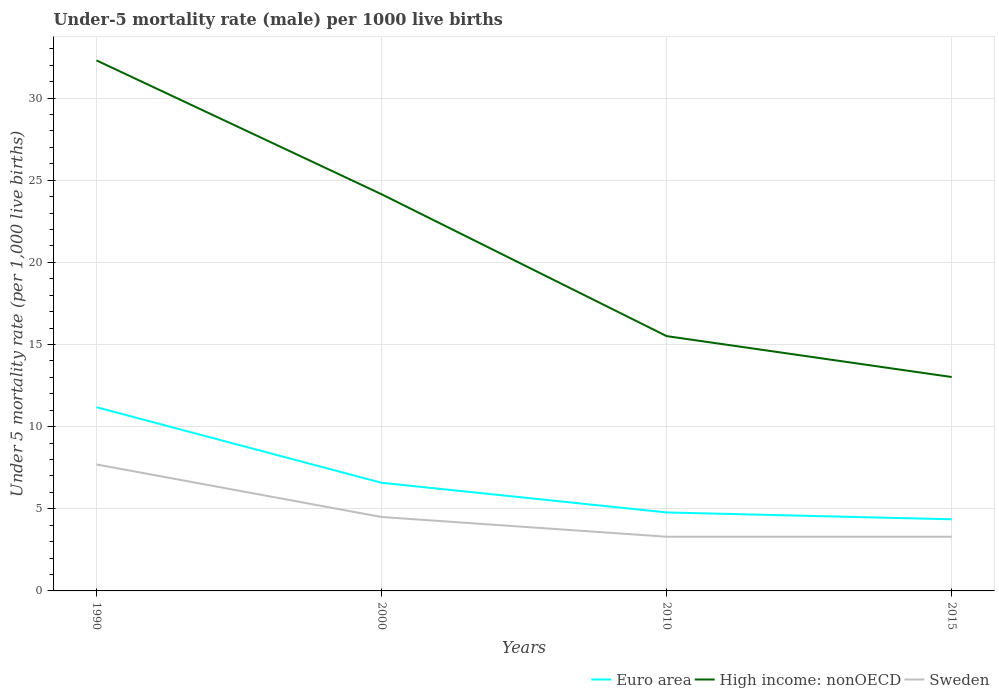How many different coloured lines are there?
Make the answer very short. 3. Across all years, what is the maximum under-five mortality rate in High income: nonOECD?
Give a very brief answer. 13.02. In which year was the under-five mortality rate in Sweden maximum?
Your response must be concise. 2010. What is the total under-five mortality rate in Euro area in the graph?
Make the answer very short. 2.22. What is the difference between the highest and the second highest under-five mortality rate in High income: nonOECD?
Give a very brief answer. 19.28. What is the difference between the highest and the lowest under-five mortality rate in Euro area?
Your response must be concise. 1. What is the difference between two consecutive major ticks on the Y-axis?
Make the answer very short. 5. Does the graph contain any zero values?
Give a very brief answer. No. How are the legend labels stacked?
Keep it short and to the point. Horizontal. What is the title of the graph?
Provide a succinct answer. Under-5 mortality rate (male) per 1000 live births. What is the label or title of the X-axis?
Your response must be concise. Years. What is the label or title of the Y-axis?
Make the answer very short. Under 5 mortality rate (per 1,0 live births). What is the Under 5 mortality rate (per 1,000 live births) of Euro area in 1990?
Offer a very short reply. 11.19. What is the Under 5 mortality rate (per 1,000 live births) of High income: nonOECD in 1990?
Your response must be concise. 32.3. What is the Under 5 mortality rate (per 1,000 live births) in Euro area in 2000?
Keep it short and to the point. 6.58. What is the Under 5 mortality rate (per 1,000 live births) of High income: nonOECD in 2000?
Provide a short and direct response. 24.15. What is the Under 5 mortality rate (per 1,000 live births) in Euro area in 2010?
Your response must be concise. 4.78. What is the Under 5 mortality rate (per 1,000 live births) of High income: nonOECD in 2010?
Your answer should be compact. 15.51. What is the Under 5 mortality rate (per 1,000 live births) in Sweden in 2010?
Provide a short and direct response. 3.3. What is the Under 5 mortality rate (per 1,000 live births) of Euro area in 2015?
Make the answer very short. 4.36. What is the Under 5 mortality rate (per 1,000 live births) of High income: nonOECD in 2015?
Give a very brief answer. 13.02. What is the Under 5 mortality rate (per 1,000 live births) of Sweden in 2015?
Offer a very short reply. 3.3. Across all years, what is the maximum Under 5 mortality rate (per 1,000 live births) in Euro area?
Your answer should be compact. 11.19. Across all years, what is the maximum Under 5 mortality rate (per 1,000 live births) in High income: nonOECD?
Give a very brief answer. 32.3. Across all years, what is the minimum Under 5 mortality rate (per 1,000 live births) in Euro area?
Make the answer very short. 4.36. Across all years, what is the minimum Under 5 mortality rate (per 1,000 live births) in High income: nonOECD?
Ensure brevity in your answer.  13.02. Across all years, what is the minimum Under 5 mortality rate (per 1,000 live births) of Sweden?
Your answer should be very brief. 3.3. What is the total Under 5 mortality rate (per 1,000 live births) in Euro area in the graph?
Offer a very short reply. 26.91. What is the total Under 5 mortality rate (per 1,000 live births) in High income: nonOECD in the graph?
Your answer should be compact. 84.98. What is the total Under 5 mortality rate (per 1,000 live births) in Sweden in the graph?
Offer a terse response. 18.8. What is the difference between the Under 5 mortality rate (per 1,000 live births) in Euro area in 1990 and that in 2000?
Your answer should be compact. 4.6. What is the difference between the Under 5 mortality rate (per 1,000 live births) of High income: nonOECD in 1990 and that in 2000?
Keep it short and to the point. 8.15. What is the difference between the Under 5 mortality rate (per 1,000 live births) of Sweden in 1990 and that in 2000?
Offer a terse response. 3.2. What is the difference between the Under 5 mortality rate (per 1,000 live births) in Euro area in 1990 and that in 2010?
Offer a terse response. 6.41. What is the difference between the Under 5 mortality rate (per 1,000 live births) of High income: nonOECD in 1990 and that in 2010?
Make the answer very short. 16.79. What is the difference between the Under 5 mortality rate (per 1,000 live births) in Euro area in 1990 and that in 2015?
Your answer should be very brief. 6.83. What is the difference between the Under 5 mortality rate (per 1,000 live births) in High income: nonOECD in 1990 and that in 2015?
Ensure brevity in your answer.  19.28. What is the difference between the Under 5 mortality rate (per 1,000 live births) of Sweden in 1990 and that in 2015?
Offer a very short reply. 4.4. What is the difference between the Under 5 mortality rate (per 1,000 live births) of Euro area in 2000 and that in 2010?
Keep it short and to the point. 1.81. What is the difference between the Under 5 mortality rate (per 1,000 live births) in High income: nonOECD in 2000 and that in 2010?
Ensure brevity in your answer.  8.64. What is the difference between the Under 5 mortality rate (per 1,000 live births) in Euro area in 2000 and that in 2015?
Provide a succinct answer. 2.22. What is the difference between the Under 5 mortality rate (per 1,000 live births) in High income: nonOECD in 2000 and that in 2015?
Your response must be concise. 11.13. What is the difference between the Under 5 mortality rate (per 1,000 live births) in Sweden in 2000 and that in 2015?
Give a very brief answer. 1.2. What is the difference between the Under 5 mortality rate (per 1,000 live births) in Euro area in 2010 and that in 2015?
Your response must be concise. 0.42. What is the difference between the Under 5 mortality rate (per 1,000 live births) in High income: nonOECD in 2010 and that in 2015?
Offer a very short reply. 2.49. What is the difference between the Under 5 mortality rate (per 1,000 live births) in Euro area in 1990 and the Under 5 mortality rate (per 1,000 live births) in High income: nonOECD in 2000?
Provide a short and direct response. -12.96. What is the difference between the Under 5 mortality rate (per 1,000 live births) in Euro area in 1990 and the Under 5 mortality rate (per 1,000 live births) in Sweden in 2000?
Provide a short and direct response. 6.69. What is the difference between the Under 5 mortality rate (per 1,000 live births) in High income: nonOECD in 1990 and the Under 5 mortality rate (per 1,000 live births) in Sweden in 2000?
Make the answer very short. 27.8. What is the difference between the Under 5 mortality rate (per 1,000 live births) in Euro area in 1990 and the Under 5 mortality rate (per 1,000 live births) in High income: nonOECD in 2010?
Give a very brief answer. -4.33. What is the difference between the Under 5 mortality rate (per 1,000 live births) in Euro area in 1990 and the Under 5 mortality rate (per 1,000 live births) in Sweden in 2010?
Your answer should be compact. 7.89. What is the difference between the Under 5 mortality rate (per 1,000 live births) of High income: nonOECD in 1990 and the Under 5 mortality rate (per 1,000 live births) of Sweden in 2010?
Keep it short and to the point. 29. What is the difference between the Under 5 mortality rate (per 1,000 live births) of Euro area in 1990 and the Under 5 mortality rate (per 1,000 live births) of High income: nonOECD in 2015?
Your response must be concise. -1.84. What is the difference between the Under 5 mortality rate (per 1,000 live births) of Euro area in 1990 and the Under 5 mortality rate (per 1,000 live births) of Sweden in 2015?
Make the answer very short. 7.89. What is the difference between the Under 5 mortality rate (per 1,000 live births) in High income: nonOECD in 1990 and the Under 5 mortality rate (per 1,000 live births) in Sweden in 2015?
Give a very brief answer. 29. What is the difference between the Under 5 mortality rate (per 1,000 live births) in Euro area in 2000 and the Under 5 mortality rate (per 1,000 live births) in High income: nonOECD in 2010?
Your response must be concise. -8.93. What is the difference between the Under 5 mortality rate (per 1,000 live births) in Euro area in 2000 and the Under 5 mortality rate (per 1,000 live births) in Sweden in 2010?
Ensure brevity in your answer.  3.28. What is the difference between the Under 5 mortality rate (per 1,000 live births) in High income: nonOECD in 2000 and the Under 5 mortality rate (per 1,000 live births) in Sweden in 2010?
Keep it short and to the point. 20.85. What is the difference between the Under 5 mortality rate (per 1,000 live births) in Euro area in 2000 and the Under 5 mortality rate (per 1,000 live births) in High income: nonOECD in 2015?
Provide a short and direct response. -6.44. What is the difference between the Under 5 mortality rate (per 1,000 live births) of Euro area in 2000 and the Under 5 mortality rate (per 1,000 live births) of Sweden in 2015?
Provide a short and direct response. 3.28. What is the difference between the Under 5 mortality rate (per 1,000 live births) in High income: nonOECD in 2000 and the Under 5 mortality rate (per 1,000 live births) in Sweden in 2015?
Make the answer very short. 20.85. What is the difference between the Under 5 mortality rate (per 1,000 live births) in Euro area in 2010 and the Under 5 mortality rate (per 1,000 live births) in High income: nonOECD in 2015?
Provide a succinct answer. -8.24. What is the difference between the Under 5 mortality rate (per 1,000 live births) of Euro area in 2010 and the Under 5 mortality rate (per 1,000 live births) of Sweden in 2015?
Give a very brief answer. 1.48. What is the difference between the Under 5 mortality rate (per 1,000 live births) in High income: nonOECD in 2010 and the Under 5 mortality rate (per 1,000 live births) in Sweden in 2015?
Give a very brief answer. 12.21. What is the average Under 5 mortality rate (per 1,000 live births) in Euro area per year?
Ensure brevity in your answer.  6.73. What is the average Under 5 mortality rate (per 1,000 live births) in High income: nonOECD per year?
Give a very brief answer. 21.25. What is the average Under 5 mortality rate (per 1,000 live births) of Sweden per year?
Provide a succinct answer. 4.7. In the year 1990, what is the difference between the Under 5 mortality rate (per 1,000 live births) of Euro area and Under 5 mortality rate (per 1,000 live births) of High income: nonOECD?
Your answer should be very brief. -21.11. In the year 1990, what is the difference between the Under 5 mortality rate (per 1,000 live births) of Euro area and Under 5 mortality rate (per 1,000 live births) of Sweden?
Your answer should be compact. 3.49. In the year 1990, what is the difference between the Under 5 mortality rate (per 1,000 live births) in High income: nonOECD and Under 5 mortality rate (per 1,000 live births) in Sweden?
Ensure brevity in your answer.  24.6. In the year 2000, what is the difference between the Under 5 mortality rate (per 1,000 live births) in Euro area and Under 5 mortality rate (per 1,000 live births) in High income: nonOECD?
Provide a succinct answer. -17.57. In the year 2000, what is the difference between the Under 5 mortality rate (per 1,000 live births) in Euro area and Under 5 mortality rate (per 1,000 live births) in Sweden?
Keep it short and to the point. 2.08. In the year 2000, what is the difference between the Under 5 mortality rate (per 1,000 live births) of High income: nonOECD and Under 5 mortality rate (per 1,000 live births) of Sweden?
Keep it short and to the point. 19.65. In the year 2010, what is the difference between the Under 5 mortality rate (per 1,000 live births) of Euro area and Under 5 mortality rate (per 1,000 live births) of High income: nonOECD?
Give a very brief answer. -10.73. In the year 2010, what is the difference between the Under 5 mortality rate (per 1,000 live births) in Euro area and Under 5 mortality rate (per 1,000 live births) in Sweden?
Your answer should be compact. 1.48. In the year 2010, what is the difference between the Under 5 mortality rate (per 1,000 live births) in High income: nonOECD and Under 5 mortality rate (per 1,000 live births) in Sweden?
Offer a terse response. 12.21. In the year 2015, what is the difference between the Under 5 mortality rate (per 1,000 live births) in Euro area and Under 5 mortality rate (per 1,000 live births) in High income: nonOECD?
Ensure brevity in your answer.  -8.66. In the year 2015, what is the difference between the Under 5 mortality rate (per 1,000 live births) in Euro area and Under 5 mortality rate (per 1,000 live births) in Sweden?
Your answer should be compact. 1.06. In the year 2015, what is the difference between the Under 5 mortality rate (per 1,000 live births) in High income: nonOECD and Under 5 mortality rate (per 1,000 live births) in Sweden?
Your answer should be compact. 9.72. What is the ratio of the Under 5 mortality rate (per 1,000 live births) in Euro area in 1990 to that in 2000?
Make the answer very short. 1.7. What is the ratio of the Under 5 mortality rate (per 1,000 live births) in High income: nonOECD in 1990 to that in 2000?
Provide a short and direct response. 1.34. What is the ratio of the Under 5 mortality rate (per 1,000 live births) of Sweden in 1990 to that in 2000?
Keep it short and to the point. 1.71. What is the ratio of the Under 5 mortality rate (per 1,000 live births) in Euro area in 1990 to that in 2010?
Ensure brevity in your answer.  2.34. What is the ratio of the Under 5 mortality rate (per 1,000 live births) of High income: nonOECD in 1990 to that in 2010?
Offer a very short reply. 2.08. What is the ratio of the Under 5 mortality rate (per 1,000 live births) in Sweden in 1990 to that in 2010?
Your response must be concise. 2.33. What is the ratio of the Under 5 mortality rate (per 1,000 live births) in Euro area in 1990 to that in 2015?
Give a very brief answer. 2.57. What is the ratio of the Under 5 mortality rate (per 1,000 live births) in High income: nonOECD in 1990 to that in 2015?
Your answer should be compact. 2.48. What is the ratio of the Under 5 mortality rate (per 1,000 live births) in Sweden in 1990 to that in 2015?
Provide a short and direct response. 2.33. What is the ratio of the Under 5 mortality rate (per 1,000 live births) in Euro area in 2000 to that in 2010?
Give a very brief answer. 1.38. What is the ratio of the Under 5 mortality rate (per 1,000 live births) in High income: nonOECD in 2000 to that in 2010?
Offer a very short reply. 1.56. What is the ratio of the Under 5 mortality rate (per 1,000 live births) in Sweden in 2000 to that in 2010?
Your answer should be very brief. 1.36. What is the ratio of the Under 5 mortality rate (per 1,000 live births) in Euro area in 2000 to that in 2015?
Provide a short and direct response. 1.51. What is the ratio of the Under 5 mortality rate (per 1,000 live births) of High income: nonOECD in 2000 to that in 2015?
Offer a very short reply. 1.85. What is the ratio of the Under 5 mortality rate (per 1,000 live births) in Sweden in 2000 to that in 2015?
Your answer should be very brief. 1.36. What is the ratio of the Under 5 mortality rate (per 1,000 live births) of Euro area in 2010 to that in 2015?
Offer a very short reply. 1.1. What is the ratio of the Under 5 mortality rate (per 1,000 live births) of High income: nonOECD in 2010 to that in 2015?
Your answer should be very brief. 1.19. What is the ratio of the Under 5 mortality rate (per 1,000 live births) of Sweden in 2010 to that in 2015?
Ensure brevity in your answer.  1. What is the difference between the highest and the second highest Under 5 mortality rate (per 1,000 live births) of Euro area?
Offer a very short reply. 4.6. What is the difference between the highest and the second highest Under 5 mortality rate (per 1,000 live births) of High income: nonOECD?
Ensure brevity in your answer.  8.15. What is the difference between the highest and the lowest Under 5 mortality rate (per 1,000 live births) of Euro area?
Offer a terse response. 6.83. What is the difference between the highest and the lowest Under 5 mortality rate (per 1,000 live births) of High income: nonOECD?
Provide a short and direct response. 19.28. 